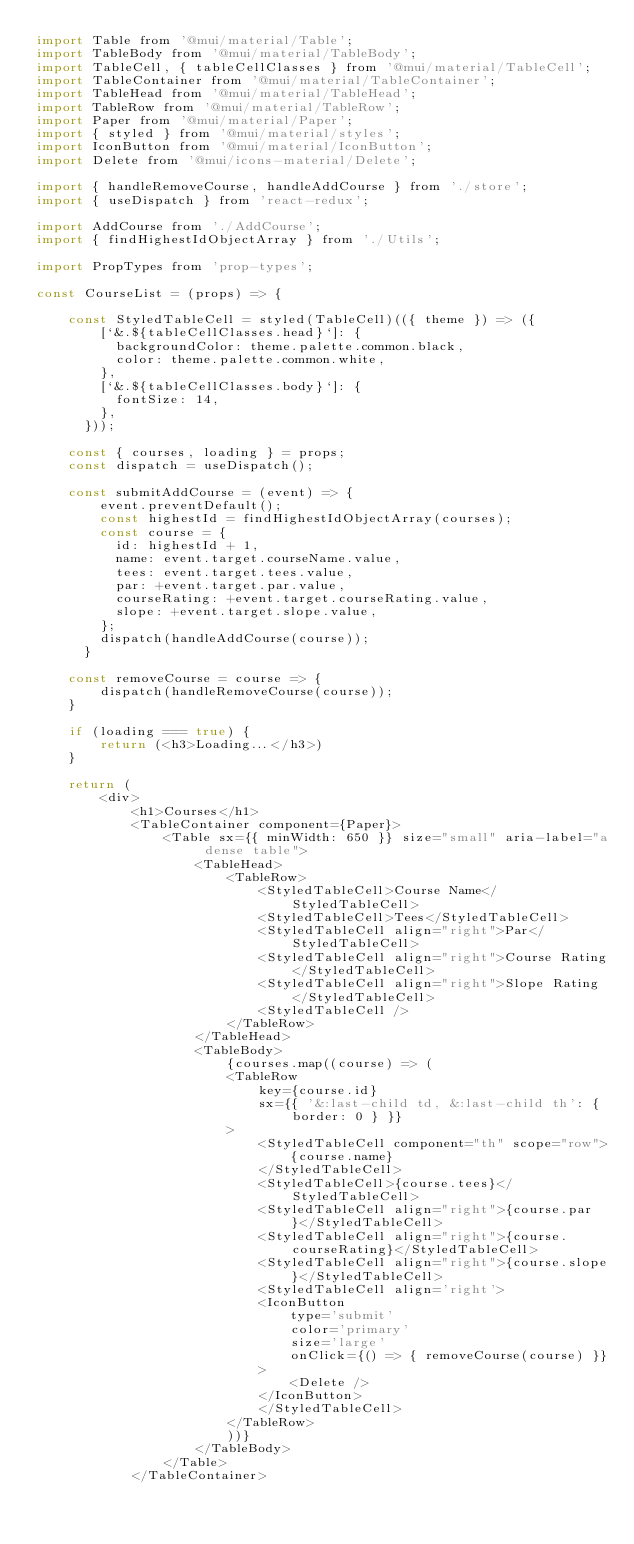<code> <loc_0><loc_0><loc_500><loc_500><_JavaScript_>import Table from '@mui/material/Table';
import TableBody from '@mui/material/TableBody';
import TableCell, { tableCellClasses } from '@mui/material/TableCell';
import TableContainer from '@mui/material/TableContainer';
import TableHead from '@mui/material/TableHead';
import TableRow from '@mui/material/TableRow';
import Paper from '@mui/material/Paper';
import { styled } from '@mui/material/styles';
import IconButton from '@mui/material/IconButton';
import Delete from '@mui/icons-material/Delete';

import { handleRemoveCourse, handleAddCourse } from './store';
import { useDispatch } from 'react-redux';

import AddCourse from './AddCourse';
import { findHighestIdObjectArray } from './Utils';

import PropTypes from 'prop-types';

const CourseList = (props) => {

    const StyledTableCell = styled(TableCell)(({ theme }) => ({
        [`&.${tableCellClasses.head}`]: {
          backgroundColor: theme.palette.common.black,
          color: theme.palette.common.white,
        },
        [`&.${tableCellClasses.body}`]: {
          fontSize: 14,
        },
      }));

    const { courses, loading } = props;
    const dispatch = useDispatch();

    const submitAddCourse = (event) => {
        event.preventDefault();
        const highestId = findHighestIdObjectArray(courses);
        const course = {
          id: highestId + 1,
          name: event.target.courseName.value,
          tees: event.target.tees.value,
          par: +event.target.par.value,
          courseRating: +event.target.courseRating.value,
          slope: +event.target.slope.value,
        };
        dispatch(handleAddCourse(course));
      }

    const removeCourse = course => {
        dispatch(handleRemoveCourse(course));
    }

    if (loading === true) {
        return (<h3>Loading...</h3>)
    }

    return (
        <div>
            <h1>Courses</h1>
            <TableContainer component={Paper}>
                <Table sx={{ minWidth: 650 }} size="small" aria-label="a dense table">
                    <TableHead>
                        <TableRow>
                            <StyledTableCell>Course Name</StyledTableCell>
                            <StyledTableCell>Tees</StyledTableCell>
                            <StyledTableCell align="right">Par</StyledTableCell>
                            <StyledTableCell align="right">Course Rating</StyledTableCell>
                            <StyledTableCell align="right">Slope Rating</StyledTableCell>
                            <StyledTableCell />
                        </TableRow>
                    </TableHead>
                    <TableBody>
                        {courses.map((course) => (
                        <TableRow
                            key={course.id}
                            sx={{ '&:last-child td, &:last-child th': { border: 0 } }}
                        >
                            <StyledTableCell component="th" scope="row">
                                {course.name}
                            </StyledTableCell>
                            <StyledTableCell>{course.tees}</StyledTableCell>
                            <StyledTableCell align="right">{course.par}</StyledTableCell>
                            <StyledTableCell align="right">{course.courseRating}</StyledTableCell>
                            <StyledTableCell align="right">{course.slope}</StyledTableCell>
                            <StyledTableCell align='right'>
                            <IconButton
                                type='submit'
                                color='primary'
                                size='large'
                                onClick={() => { removeCourse(course) }}
                            >
                                <Delete />
                            </IconButton>
                            </StyledTableCell>
                        </TableRow>
                        ))}
                    </TableBody>
                </Table>
            </TableContainer></code> 